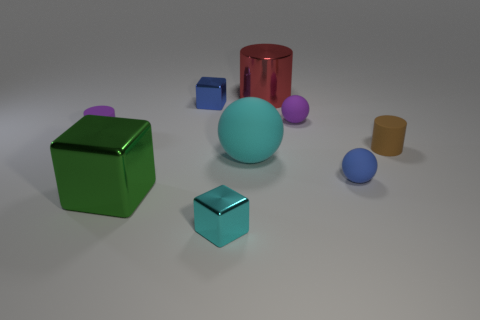What is the material of the object on the left side of the large metal object that is in front of the large matte object?
Your answer should be very brief. Rubber. There is a cylinder that is to the right of the purple cylinder and in front of the tiny purple ball; what material is it made of?
Keep it short and to the point. Rubber. What number of metal things have the same color as the large ball?
Keep it short and to the point. 1. Is the color of the big sphere the same as the tiny metal thing in front of the green metal block?
Make the answer very short. Yes. Do the purple rubber object on the right side of the large cylinder and the small blue matte thing have the same shape?
Make the answer very short. Yes. Are there any small cyan metallic cubes on the left side of the tiny brown object?
Keep it short and to the point. Yes. How many small objects are green shiny cubes or blue matte blocks?
Your response must be concise. 0. Is the cyan ball made of the same material as the tiny brown cylinder?
Your response must be concise. Yes. What is the size of the shiny cube that is the same color as the big rubber thing?
Make the answer very short. Small. Is there a shiny cube of the same color as the big rubber thing?
Keep it short and to the point. Yes. 